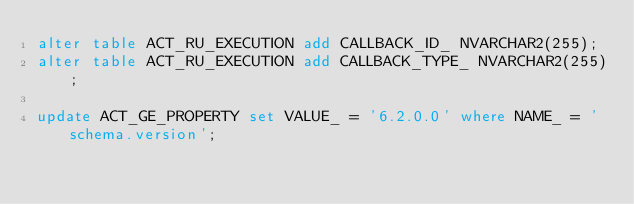Convert code to text. <code><loc_0><loc_0><loc_500><loc_500><_SQL_>alter table ACT_RU_EXECUTION add CALLBACK_ID_ NVARCHAR2(255);
alter table ACT_RU_EXECUTION add CALLBACK_TYPE_ NVARCHAR2(255);

update ACT_GE_PROPERTY set VALUE_ = '6.2.0.0' where NAME_ = 'schema.version';</code> 